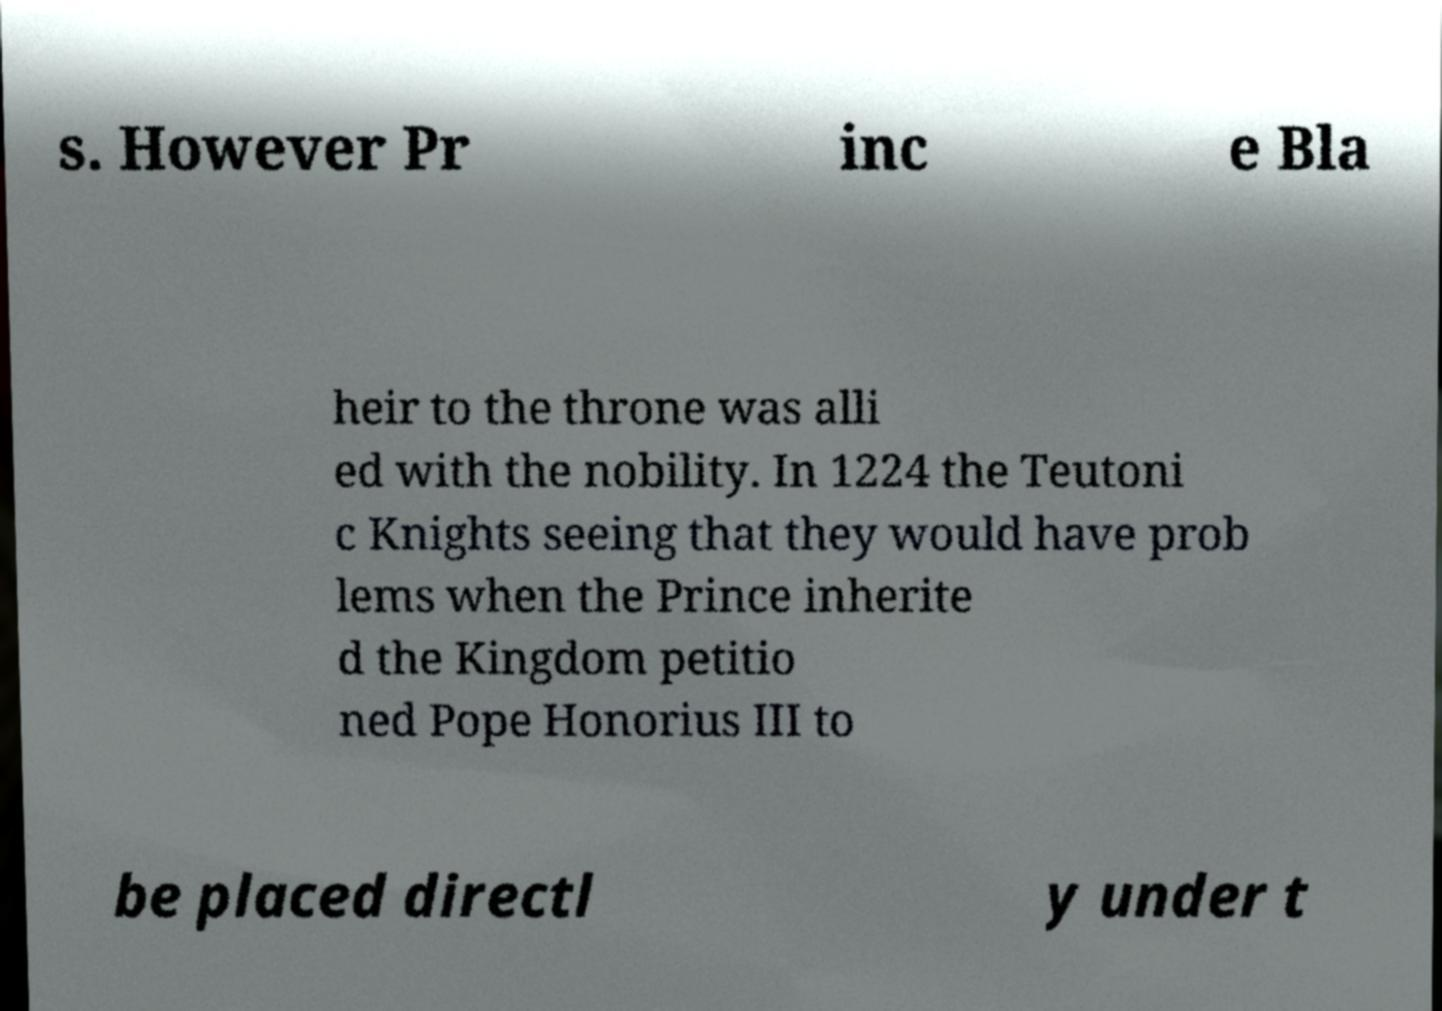I need the written content from this picture converted into text. Can you do that? s. However Pr inc e Bla heir to the throne was alli ed with the nobility. In 1224 the Teutoni c Knights seeing that they would have prob lems when the Prince inherite d the Kingdom petitio ned Pope Honorius III to be placed directl y under t 